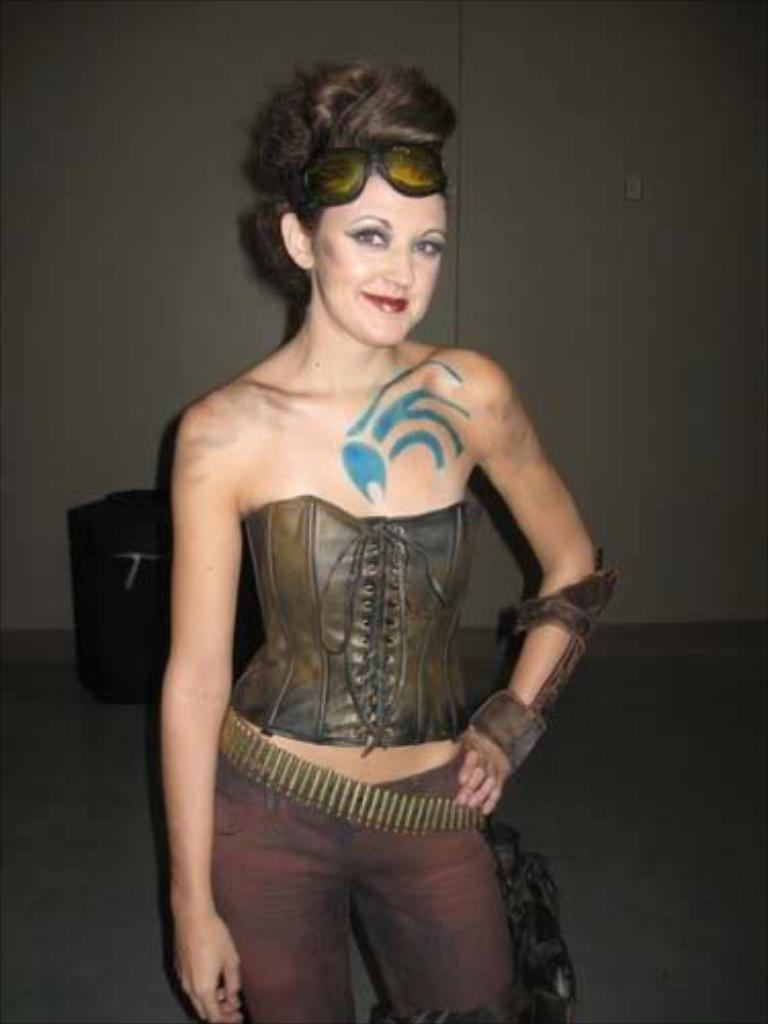Who is present in the image? There is a woman in the image. What is the woman doing in the image? The woman is smiling and standing. What can be seen in the background of the image? There is an object on the floor and a wall visible in the background of the image. What subject is the woman teaching in the image? There is no indication in the image that the woman is teaching any subject. How many chickens are present in the image? There are no chickens present in the image. 